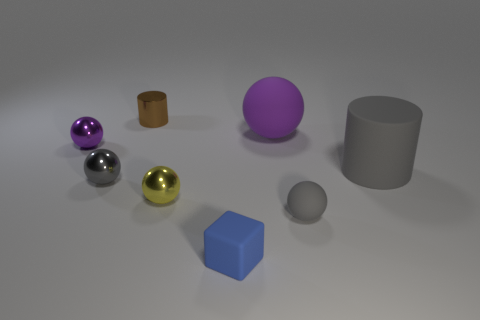Subtract all large rubber spheres. How many spheres are left? 4 Subtract all yellow spheres. How many spheres are left? 4 Add 2 large blue rubber cubes. How many objects exist? 10 Subtract all gray cubes. How many gray spheres are left? 2 Subtract all cubes. How many objects are left? 7 Add 6 purple rubber objects. How many purple rubber objects are left? 7 Add 7 purple balls. How many purple balls exist? 9 Subtract 0 green balls. How many objects are left? 8 Subtract 1 spheres. How many spheres are left? 4 Subtract all purple cylinders. Subtract all yellow cubes. How many cylinders are left? 2 